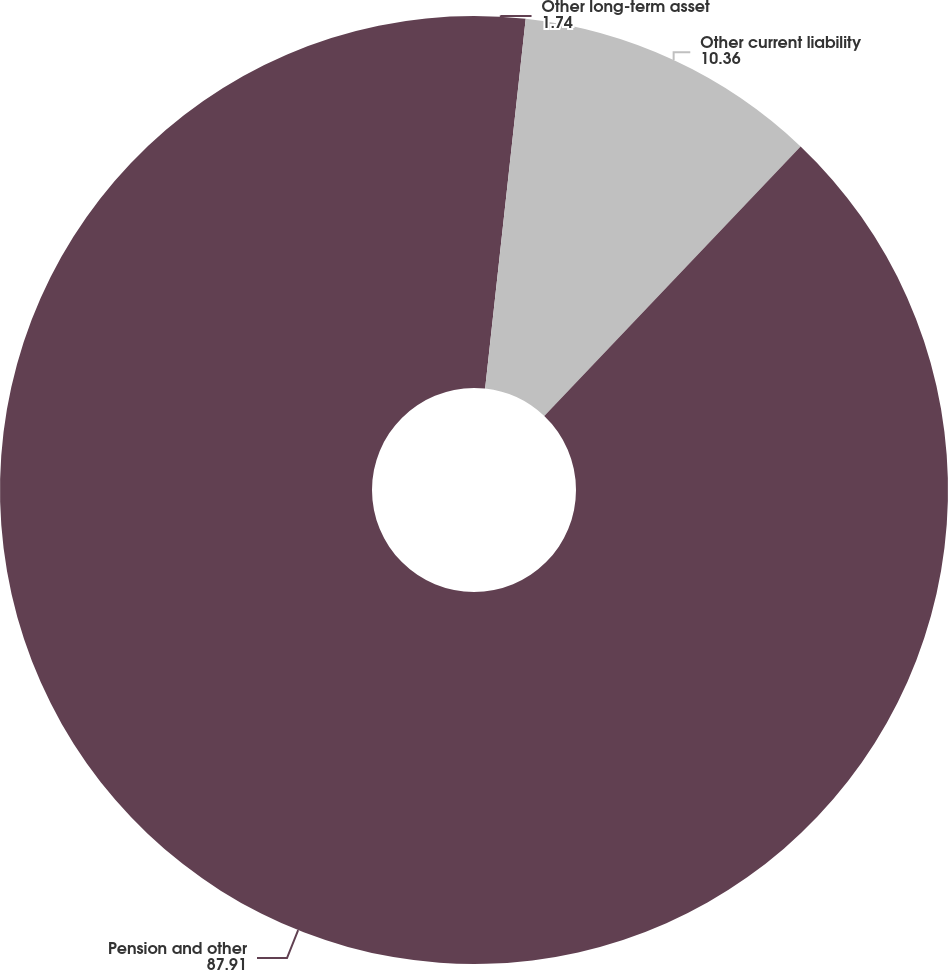Convert chart to OTSL. <chart><loc_0><loc_0><loc_500><loc_500><pie_chart><fcel>Other long-term asset<fcel>Other current liability<fcel>Pension and other<nl><fcel>1.74%<fcel>10.36%<fcel>87.91%<nl></chart> 